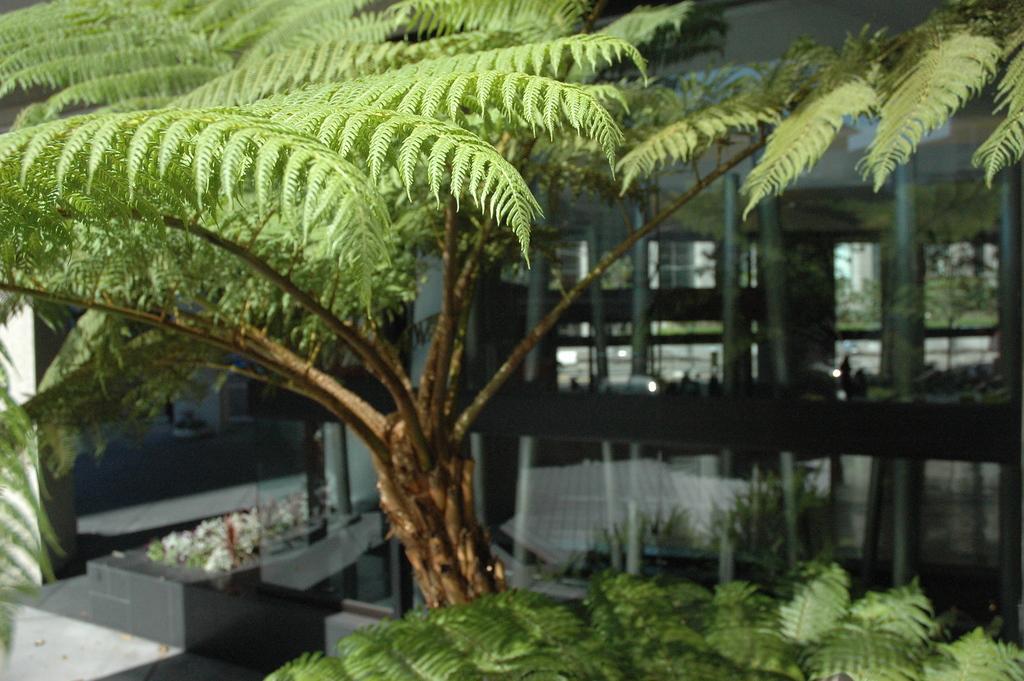Could you give a brief overview of what you see in this image? In this image we can see some plants. On the backside we can see a building with pillars. On the left side we can see some flowers. 